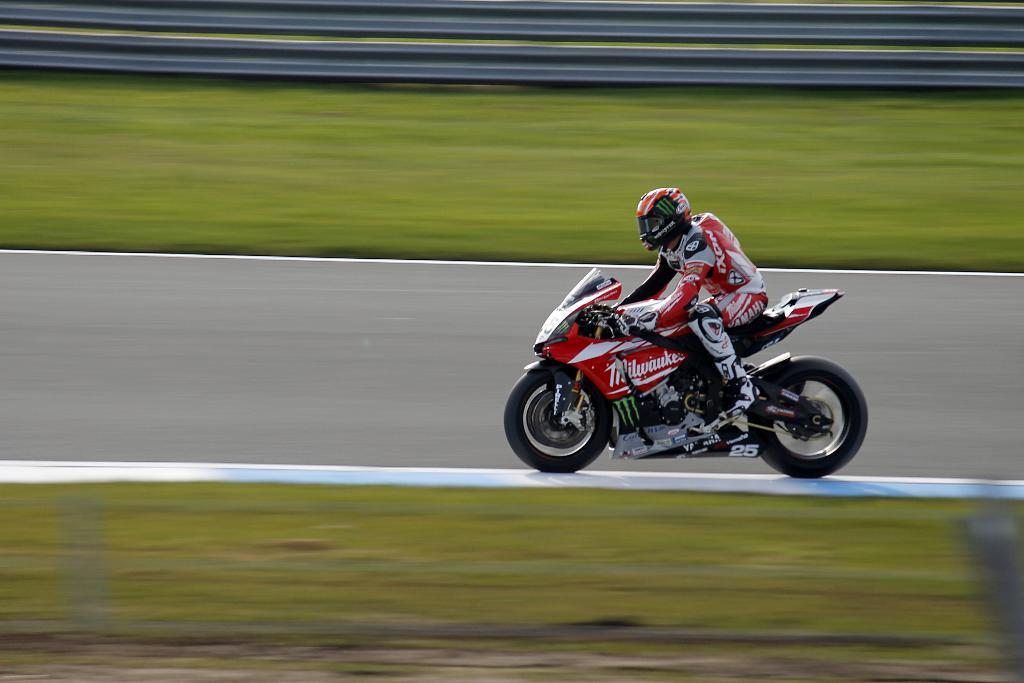Where was the image taken? The image was clicked outside. What is the person in the image wearing? The person is wearing a helmet in the image. What type of vehicle is the person riding? The person is riding a red color bike. What type of vegetation can be seen in the image? Green grass is visible in the image. Can you describe any other objects present in the image? There are other unspecified objects in the image. What books can be seen in the image? There are no books visible in the image. What is the person learning in the image? The image does not show the person learning anything; it only shows them riding a bike. 